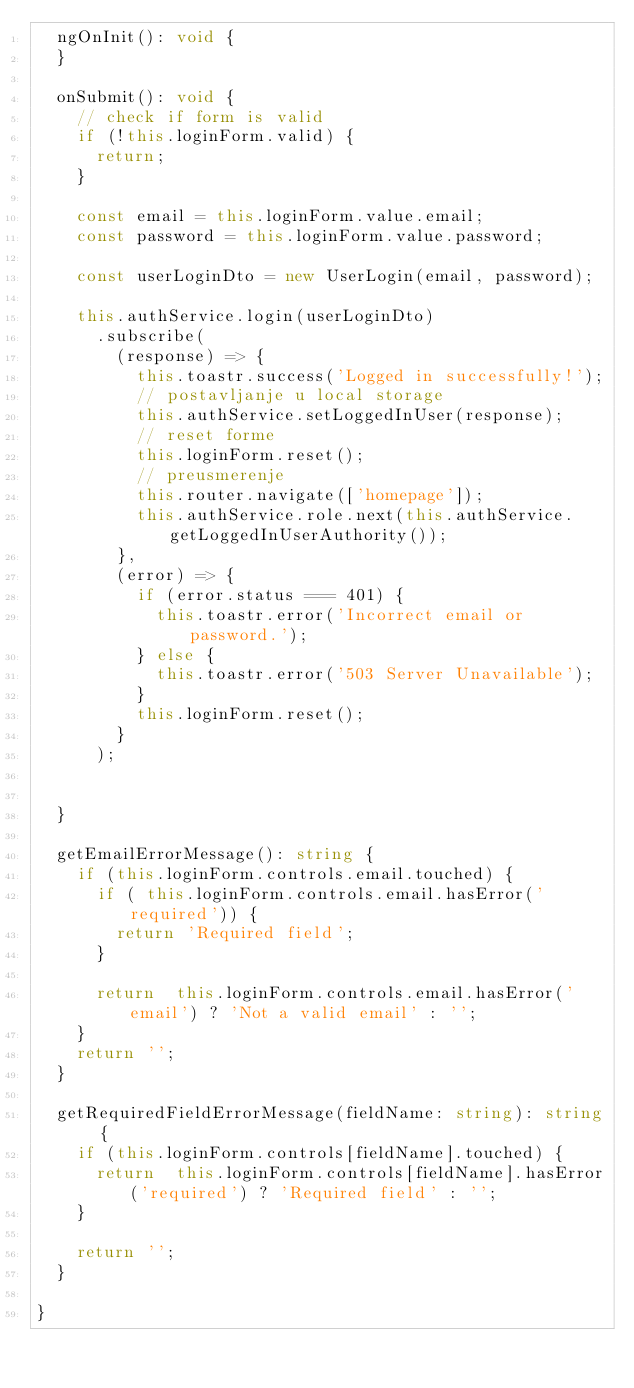Convert code to text. <code><loc_0><loc_0><loc_500><loc_500><_TypeScript_>  ngOnInit(): void {
  }

  onSubmit(): void {
    // check if form is valid
    if (!this.loginForm.valid) {
      return;
    }

    const email = this.loginForm.value.email;
    const password = this.loginForm.value.password;

    const userLoginDto = new UserLogin(email, password);

    this.authService.login(userLoginDto)
      .subscribe(
        (response) => {
          this.toastr.success('Logged in successfully!');
          // postavljanje u local storage
          this.authService.setLoggedInUser(response);
          // reset forme
          this.loginForm.reset();
          // preusmerenje
          this.router.navigate(['homepage']);
          this.authService.role.next(this.authService.getLoggedInUserAuthority());
        },
        (error) => {
          if (error.status === 401) {
            this.toastr.error('Incorrect email or password.');
          } else {
            this.toastr.error('503 Server Unavailable');
          }
          this.loginForm.reset();
        }
      );


  }

  getEmailErrorMessage(): string {
    if (this.loginForm.controls.email.touched) {
      if ( this.loginForm.controls.email.hasError('required')) {
        return 'Required field';
      }

      return  this.loginForm.controls.email.hasError('email') ? 'Not a valid email' : '';
    }
    return '';
  }

  getRequiredFieldErrorMessage(fieldName: string): string {
    if (this.loginForm.controls[fieldName].touched) {
      return  this.loginForm.controls[fieldName].hasError('required') ? 'Required field' : '';
    }

    return '';
  }

}


</code> 